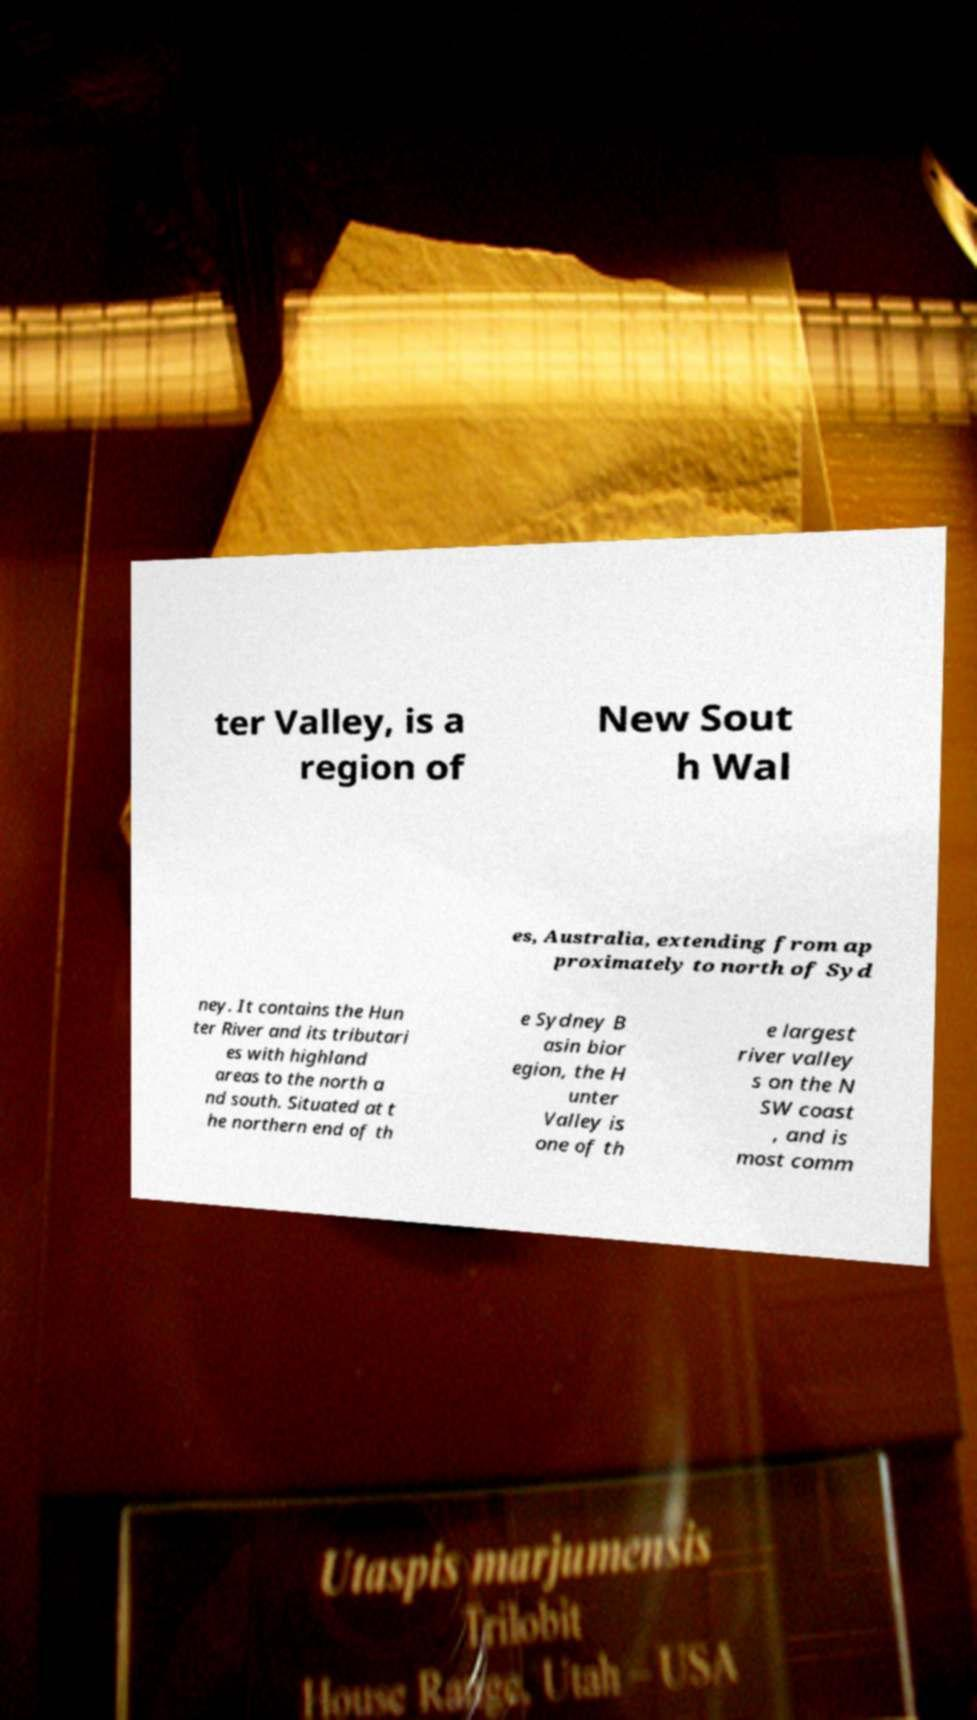Please read and relay the text visible in this image. What does it say? ter Valley, is a region of New Sout h Wal es, Australia, extending from ap proximately to north of Syd ney. It contains the Hun ter River and its tributari es with highland areas to the north a nd south. Situated at t he northern end of th e Sydney B asin bior egion, the H unter Valley is one of th e largest river valley s on the N SW coast , and is most comm 